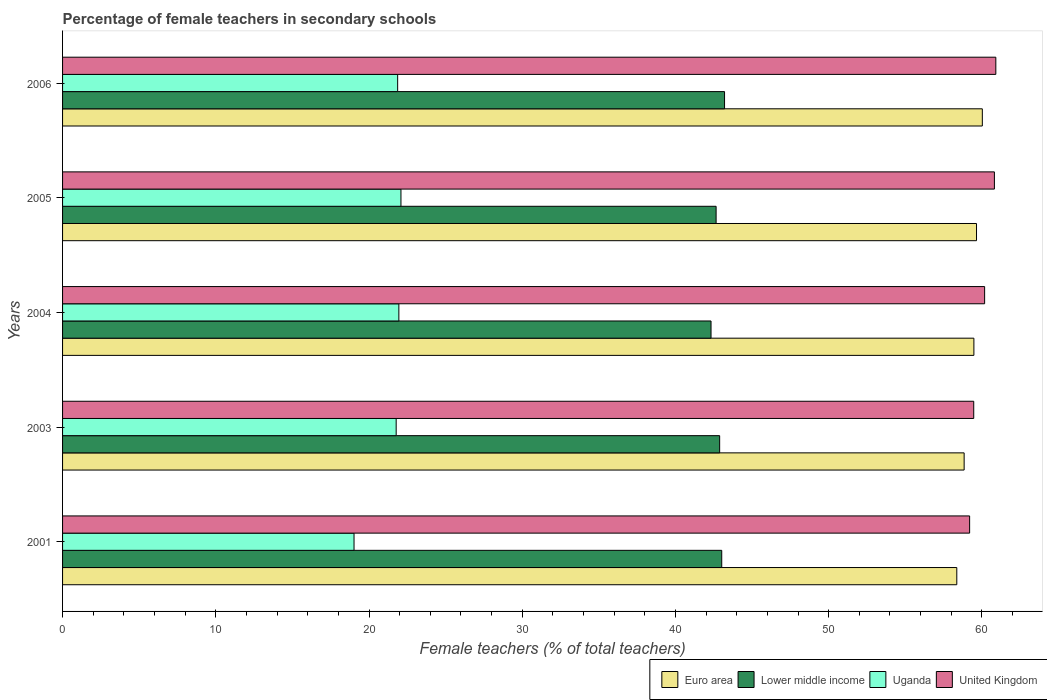How many different coloured bars are there?
Provide a succinct answer. 4. How many groups of bars are there?
Keep it short and to the point. 5. In how many cases, is the number of bars for a given year not equal to the number of legend labels?
Provide a succinct answer. 0. What is the percentage of female teachers in Lower middle income in 2004?
Your answer should be very brief. 42.32. Across all years, what is the maximum percentage of female teachers in Euro area?
Make the answer very short. 60.03. Across all years, what is the minimum percentage of female teachers in Uganda?
Your answer should be compact. 19.02. In which year was the percentage of female teachers in Euro area minimum?
Provide a short and direct response. 2001. What is the total percentage of female teachers in Uganda in the graph?
Give a very brief answer. 106.7. What is the difference between the percentage of female teachers in Lower middle income in 2001 and that in 2005?
Your response must be concise. 0.37. What is the difference between the percentage of female teachers in United Kingdom in 2006 and the percentage of female teachers in Lower middle income in 2001?
Your response must be concise. 17.89. What is the average percentage of female teachers in Lower middle income per year?
Your response must be concise. 42.82. In the year 2001, what is the difference between the percentage of female teachers in United Kingdom and percentage of female teachers in Uganda?
Give a very brief answer. 40.18. In how many years, is the percentage of female teachers in Lower middle income greater than 44 %?
Provide a short and direct response. 0. What is the ratio of the percentage of female teachers in United Kingdom in 2003 to that in 2006?
Offer a very short reply. 0.98. Is the percentage of female teachers in Lower middle income in 2003 less than that in 2004?
Offer a terse response. No. What is the difference between the highest and the second highest percentage of female teachers in United Kingdom?
Your answer should be very brief. 0.09. What is the difference between the highest and the lowest percentage of female teachers in Uganda?
Give a very brief answer. 3.06. What does the 3rd bar from the bottom in 2003 represents?
Provide a succinct answer. Uganda. How many bars are there?
Your answer should be very brief. 20. Are all the bars in the graph horizontal?
Keep it short and to the point. Yes. How many years are there in the graph?
Your response must be concise. 5. How are the legend labels stacked?
Provide a short and direct response. Horizontal. What is the title of the graph?
Your answer should be compact. Percentage of female teachers in secondary schools. Does "Morocco" appear as one of the legend labels in the graph?
Your response must be concise. No. What is the label or title of the X-axis?
Make the answer very short. Female teachers (% of total teachers). What is the Female teachers (% of total teachers) of Euro area in 2001?
Offer a terse response. 58.36. What is the Female teachers (% of total teachers) of Lower middle income in 2001?
Make the answer very short. 43.02. What is the Female teachers (% of total teachers) in Uganda in 2001?
Your response must be concise. 19.02. What is the Female teachers (% of total teachers) in United Kingdom in 2001?
Provide a succinct answer. 59.2. What is the Female teachers (% of total teachers) of Euro area in 2003?
Provide a succinct answer. 58.84. What is the Female teachers (% of total teachers) of Lower middle income in 2003?
Offer a terse response. 42.89. What is the Female teachers (% of total teachers) of Uganda in 2003?
Provide a succinct answer. 21.77. What is the Female teachers (% of total teachers) of United Kingdom in 2003?
Keep it short and to the point. 59.47. What is the Female teachers (% of total teachers) of Euro area in 2004?
Provide a short and direct response. 59.48. What is the Female teachers (% of total teachers) of Lower middle income in 2004?
Give a very brief answer. 42.32. What is the Female teachers (% of total teachers) in Uganda in 2004?
Give a very brief answer. 21.95. What is the Female teachers (% of total teachers) of United Kingdom in 2004?
Your answer should be compact. 60.18. What is the Female teachers (% of total teachers) of Euro area in 2005?
Give a very brief answer. 59.65. What is the Female teachers (% of total teachers) in Lower middle income in 2005?
Your answer should be very brief. 42.65. What is the Female teachers (% of total teachers) in Uganda in 2005?
Ensure brevity in your answer.  22.08. What is the Female teachers (% of total teachers) of United Kingdom in 2005?
Your answer should be compact. 60.82. What is the Female teachers (% of total teachers) of Euro area in 2006?
Offer a very short reply. 60.03. What is the Female teachers (% of total teachers) of Lower middle income in 2006?
Keep it short and to the point. 43.2. What is the Female teachers (% of total teachers) of Uganda in 2006?
Give a very brief answer. 21.87. What is the Female teachers (% of total teachers) of United Kingdom in 2006?
Make the answer very short. 60.91. Across all years, what is the maximum Female teachers (% of total teachers) in Euro area?
Your answer should be compact. 60.03. Across all years, what is the maximum Female teachers (% of total teachers) in Lower middle income?
Your answer should be compact. 43.2. Across all years, what is the maximum Female teachers (% of total teachers) of Uganda?
Give a very brief answer. 22.08. Across all years, what is the maximum Female teachers (% of total teachers) of United Kingdom?
Give a very brief answer. 60.91. Across all years, what is the minimum Female teachers (% of total teachers) in Euro area?
Make the answer very short. 58.36. Across all years, what is the minimum Female teachers (% of total teachers) of Lower middle income?
Make the answer very short. 42.32. Across all years, what is the minimum Female teachers (% of total teachers) of Uganda?
Offer a terse response. 19.02. Across all years, what is the minimum Female teachers (% of total teachers) of United Kingdom?
Your response must be concise. 59.2. What is the total Female teachers (% of total teachers) in Euro area in the graph?
Your answer should be very brief. 296.36. What is the total Female teachers (% of total teachers) in Lower middle income in the graph?
Ensure brevity in your answer.  214.09. What is the total Female teachers (% of total teachers) of Uganda in the graph?
Your response must be concise. 106.7. What is the total Female teachers (% of total teachers) of United Kingdom in the graph?
Make the answer very short. 300.57. What is the difference between the Female teachers (% of total teachers) of Euro area in 2001 and that in 2003?
Provide a short and direct response. -0.48. What is the difference between the Female teachers (% of total teachers) in Lower middle income in 2001 and that in 2003?
Your response must be concise. 0.14. What is the difference between the Female teachers (% of total teachers) in Uganda in 2001 and that in 2003?
Your answer should be very brief. -2.75. What is the difference between the Female teachers (% of total teachers) of United Kingdom in 2001 and that in 2003?
Offer a terse response. -0.27. What is the difference between the Female teachers (% of total teachers) in Euro area in 2001 and that in 2004?
Provide a short and direct response. -1.12. What is the difference between the Female teachers (% of total teachers) in Lower middle income in 2001 and that in 2004?
Ensure brevity in your answer.  0.7. What is the difference between the Female teachers (% of total teachers) in Uganda in 2001 and that in 2004?
Your answer should be compact. -2.93. What is the difference between the Female teachers (% of total teachers) of United Kingdom in 2001 and that in 2004?
Your answer should be very brief. -0.98. What is the difference between the Female teachers (% of total teachers) in Euro area in 2001 and that in 2005?
Give a very brief answer. -1.29. What is the difference between the Female teachers (% of total teachers) in Lower middle income in 2001 and that in 2005?
Your answer should be very brief. 0.37. What is the difference between the Female teachers (% of total teachers) of Uganda in 2001 and that in 2005?
Provide a succinct answer. -3.06. What is the difference between the Female teachers (% of total teachers) of United Kingdom in 2001 and that in 2005?
Keep it short and to the point. -1.62. What is the difference between the Female teachers (% of total teachers) of Euro area in 2001 and that in 2006?
Keep it short and to the point. -1.67. What is the difference between the Female teachers (% of total teachers) in Lower middle income in 2001 and that in 2006?
Your answer should be very brief. -0.18. What is the difference between the Female teachers (% of total teachers) of Uganda in 2001 and that in 2006?
Provide a succinct answer. -2.85. What is the difference between the Female teachers (% of total teachers) of United Kingdom in 2001 and that in 2006?
Your answer should be very brief. -1.71. What is the difference between the Female teachers (% of total teachers) of Euro area in 2003 and that in 2004?
Offer a very short reply. -0.64. What is the difference between the Female teachers (% of total teachers) in Lower middle income in 2003 and that in 2004?
Your answer should be very brief. 0.56. What is the difference between the Female teachers (% of total teachers) of Uganda in 2003 and that in 2004?
Keep it short and to the point. -0.18. What is the difference between the Female teachers (% of total teachers) of United Kingdom in 2003 and that in 2004?
Your response must be concise. -0.71. What is the difference between the Female teachers (% of total teachers) of Euro area in 2003 and that in 2005?
Offer a terse response. -0.81. What is the difference between the Female teachers (% of total teachers) of Lower middle income in 2003 and that in 2005?
Offer a terse response. 0.23. What is the difference between the Female teachers (% of total teachers) in Uganda in 2003 and that in 2005?
Give a very brief answer. -0.31. What is the difference between the Female teachers (% of total teachers) of United Kingdom in 2003 and that in 2005?
Your answer should be compact. -1.35. What is the difference between the Female teachers (% of total teachers) in Euro area in 2003 and that in 2006?
Give a very brief answer. -1.19. What is the difference between the Female teachers (% of total teachers) of Lower middle income in 2003 and that in 2006?
Give a very brief answer. -0.32. What is the difference between the Female teachers (% of total teachers) in Uganda in 2003 and that in 2006?
Make the answer very short. -0.1. What is the difference between the Female teachers (% of total teachers) of United Kingdom in 2003 and that in 2006?
Your answer should be compact. -1.44. What is the difference between the Female teachers (% of total teachers) of Euro area in 2004 and that in 2005?
Give a very brief answer. -0.17. What is the difference between the Female teachers (% of total teachers) in Lower middle income in 2004 and that in 2005?
Your response must be concise. -0.33. What is the difference between the Female teachers (% of total teachers) in Uganda in 2004 and that in 2005?
Your response must be concise. -0.14. What is the difference between the Female teachers (% of total teachers) in United Kingdom in 2004 and that in 2005?
Ensure brevity in your answer.  -0.64. What is the difference between the Female teachers (% of total teachers) of Euro area in 2004 and that in 2006?
Keep it short and to the point. -0.55. What is the difference between the Female teachers (% of total teachers) of Lower middle income in 2004 and that in 2006?
Make the answer very short. -0.88. What is the difference between the Female teachers (% of total teachers) of Uganda in 2004 and that in 2006?
Provide a short and direct response. 0.08. What is the difference between the Female teachers (% of total teachers) in United Kingdom in 2004 and that in 2006?
Provide a short and direct response. -0.73. What is the difference between the Female teachers (% of total teachers) in Euro area in 2005 and that in 2006?
Keep it short and to the point. -0.38. What is the difference between the Female teachers (% of total teachers) in Lower middle income in 2005 and that in 2006?
Make the answer very short. -0.55. What is the difference between the Female teachers (% of total teachers) of Uganda in 2005 and that in 2006?
Your answer should be very brief. 0.21. What is the difference between the Female teachers (% of total teachers) in United Kingdom in 2005 and that in 2006?
Provide a succinct answer. -0.09. What is the difference between the Female teachers (% of total teachers) of Euro area in 2001 and the Female teachers (% of total teachers) of Lower middle income in 2003?
Provide a short and direct response. 15.48. What is the difference between the Female teachers (% of total teachers) in Euro area in 2001 and the Female teachers (% of total teachers) in Uganda in 2003?
Your answer should be very brief. 36.59. What is the difference between the Female teachers (% of total teachers) in Euro area in 2001 and the Female teachers (% of total teachers) in United Kingdom in 2003?
Provide a succinct answer. -1.11. What is the difference between the Female teachers (% of total teachers) of Lower middle income in 2001 and the Female teachers (% of total teachers) of Uganda in 2003?
Provide a short and direct response. 21.25. What is the difference between the Female teachers (% of total teachers) in Lower middle income in 2001 and the Female teachers (% of total teachers) in United Kingdom in 2003?
Your answer should be very brief. -16.45. What is the difference between the Female teachers (% of total teachers) in Uganda in 2001 and the Female teachers (% of total teachers) in United Kingdom in 2003?
Give a very brief answer. -40.45. What is the difference between the Female teachers (% of total teachers) of Euro area in 2001 and the Female teachers (% of total teachers) of Lower middle income in 2004?
Your answer should be compact. 16.04. What is the difference between the Female teachers (% of total teachers) in Euro area in 2001 and the Female teachers (% of total teachers) in Uganda in 2004?
Offer a very short reply. 36.41. What is the difference between the Female teachers (% of total teachers) of Euro area in 2001 and the Female teachers (% of total teachers) of United Kingdom in 2004?
Give a very brief answer. -1.82. What is the difference between the Female teachers (% of total teachers) in Lower middle income in 2001 and the Female teachers (% of total teachers) in Uganda in 2004?
Keep it short and to the point. 21.07. What is the difference between the Female teachers (% of total teachers) of Lower middle income in 2001 and the Female teachers (% of total teachers) of United Kingdom in 2004?
Offer a very short reply. -17.16. What is the difference between the Female teachers (% of total teachers) of Uganda in 2001 and the Female teachers (% of total teachers) of United Kingdom in 2004?
Give a very brief answer. -41.16. What is the difference between the Female teachers (% of total teachers) of Euro area in 2001 and the Female teachers (% of total teachers) of Lower middle income in 2005?
Give a very brief answer. 15.71. What is the difference between the Female teachers (% of total teachers) in Euro area in 2001 and the Female teachers (% of total teachers) in Uganda in 2005?
Offer a very short reply. 36.28. What is the difference between the Female teachers (% of total teachers) in Euro area in 2001 and the Female teachers (% of total teachers) in United Kingdom in 2005?
Offer a terse response. -2.45. What is the difference between the Female teachers (% of total teachers) of Lower middle income in 2001 and the Female teachers (% of total teachers) of Uganda in 2005?
Make the answer very short. 20.94. What is the difference between the Female teachers (% of total teachers) of Lower middle income in 2001 and the Female teachers (% of total teachers) of United Kingdom in 2005?
Provide a short and direct response. -17.8. What is the difference between the Female teachers (% of total teachers) of Uganda in 2001 and the Female teachers (% of total teachers) of United Kingdom in 2005?
Ensure brevity in your answer.  -41.79. What is the difference between the Female teachers (% of total teachers) of Euro area in 2001 and the Female teachers (% of total teachers) of Lower middle income in 2006?
Offer a very short reply. 15.16. What is the difference between the Female teachers (% of total teachers) of Euro area in 2001 and the Female teachers (% of total teachers) of Uganda in 2006?
Provide a short and direct response. 36.49. What is the difference between the Female teachers (% of total teachers) in Euro area in 2001 and the Female teachers (% of total teachers) in United Kingdom in 2006?
Provide a succinct answer. -2.55. What is the difference between the Female teachers (% of total teachers) in Lower middle income in 2001 and the Female teachers (% of total teachers) in Uganda in 2006?
Keep it short and to the point. 21.15. What is the difference between the Female teachers (% of total teachers) in Lower middle income in 2001 and the Female teachers (% of total teachers) in United Kingdom in 2006?
Ensure brevity in your answer.  -17.89. What is the difference between the Female teachers (% of total teachers) of Uganda in 2001 and the Female teachers (% of total teachers) of United Kingdom in 2006?
Make the answer very short. -41.89. What is the difference between the Female teachers (% of total teachers) of Euro area in 2003 and the Female teachers (% of total teachers) of Lower middle income in 2004?
Ensure brevity in your answer.  16.52. What is the difference between the Female teachers (% of total teachers) in Euro area in 2003 and the Female teachers (% of total teachers) in Uganda in 2004?
Provide a succinct answer. 36.89. What is the difference between the Female teachers (% of total teachers) in Euro area in 2003 and the Female teachers (% of total teachers) in United Kingdom in 2004?
Your response must be concise. -1.34. What is the difference between the Female teachers (% of total teachers) of Lower middle income in 2003 and the Female teachers (% of total teachers) of Uganda in 2004?
Give a very brief answer. 20.94. What is the difference between the Female teachers (% of total teachers) in Lower middle income in 2003 and the Female teachers (% of total teachers) in United Kingdom in 2004?
Your answer should be very brief. -17.29. What is the difference between the Female teachers (% of total teachers) in Uganda in 2003 and the Female teachers (% of total teachers) in United Kingdom in 2004?
Provide a succinct answer. -38.41. What is the difference between the Female teachers (% of total teachers) of Euro area in 2003 and the Female teachers (% of total teachers) of Lower middle income in 2005?
Provide a succinct answer. 16.19. What is the difference between the Female teachers (% of total teachers) of Euro area in 2003 and the Female teachers (% of total teachers) of Uganda in 2005?
Your answer should be compact. 36.76. What is the difference between the Female teachers (% of total teachers) of Euro area in 2003 and the Female teachers (% of total teachers) of United Kingdom in 2005?
Provide a short and direct response. -1.98. What is the difference between the Female teachers (% of total teachers) in Lower middle income in 2003 and the Female teachers (% of total teachers) in Uganda in 2005?
Your response must be concise. 20.8. What is the difference between the Female teachers (% of total teachers) in Lower middle income in 2003 and the Female teachers (% of total teachers) in United Kingdom in 2005?
Provide a succinct answer. -17.93. What is the difference between the Female teachers (% of total teachers) of Uganda in 2003 and the Female teachers (% of total teachers) of United Kingdom in 2005?
Provide a short and direct response. -39.04. What is the difference between the Female teachers (% of total teachers) of Euro area in 2003 and the Female teachers (% of total teachers) of Lower middle income in 2006?
Your answer should be compact. 15.64. What is the difference between the Female teachers (% of total teachers) of Euro area in 2003 and the Female teachers (% of total teachers) of Uganda in 2006?
Ensure brevity in your answer.  36.97. What is the difference between the Female teachers (% of total teachers) in Euro area in 2003 and the Female teachers (% of total teachers) in United Kingdom in 2006?
Your response must be concise. -2.07. What is the difference between the Female teachers (% of total teachers) in Lower middle income in 2003 and the Female teachers (% of total teachers) in Uganda in 2006?
Make the answer very short. 21.02. What is the difference between the Female teachers (% of total teachers) in Lower middle income in 2003 and the Female teachers (% of total teachers) in United Kingdom in 2006?
Your answer should be compact. -18.02. What is the difference between the Female teachers (% of total teachers) of Uganda in 2003 and the Female teachers (% of total teachers) of United Kingdom in 2006?
Offer a very short reply. -39.14. What is the difference between the Female teachers (% of total teachers) in Euro area in 2004 and the Female teachers (% of total teachers) in Lower middle income in 2005?
Your response must be concise. 16.82. What is the difference between the Female teachers (% of total teachers) in Euro area in 2004 and the Female teachers (% of total teachers) in Uganda in 2005?
Provide a succinct answer. 37.39. What is the difference between the Female teachers (% of total teachers) in Euro area in 2004 and the Female teachers (% of total teachers) in United Kingdom in 2005?
Make the answer very short. -1.34. What is the difference between the Female teachers (% of total teachers) of Lower middle income in 2004 and the Female teachers (% of total teachers) of Uganda in 2005?
Provide a short and direct response. 20.24. What is the difference between the Female teachers (% of total teachers) of Lower middle income in 2004 and the Female teachers (% of total teachers) of United Kingdom in 2005?
Ensure brevity in your answer.  -18.49. What is the difference between the Female teachers (% of total teachers) in Uganda in 2004 and the Female teachers (% of total teachers) in United Kingdom in 2005?
Your response must be concise. -38.87. What is the difference between the Female teachers (% of total teachers) of Euro area in 2004 and the Female teachers (% of total teachers) of Lower middle income in 2006?
Provide a short and direct response. 16.27. What is the difference between the Female teachers (% of total teachers) in Euro area in 2004 and the Female teachers (% of total teachers) in Uganda in 2006?
Keep it short and to the point. 37.61. What is the difference between the Female teachers (% of total teachers) of Euro area in 2004 and the Female teachers (% of total teachers) of United Kingdom in 2006?
Ensure brevity in your answer.  -1.43. What is the difference between the Female teachers (% of total teachers) of Lower middle income in 2004 and the Female teachers (% of total teachers) of Uganda in 2006?
Your answer should be compact. 20.45. What is the difference between the Female teachers (% of total teachers) of Lower middle income in 2004 and the Female teachers (% of total teachers) of United Kingdom in 2006?
Offer a terse response. -18.59. What is the difference between the Female teachers (% of total teachers) in Uganda in 2004 and the Female teachers (% of total teachers) in United Kingdom in 2006?
Provide a short and direct response. -38.96. What is the difference between the Female teachers (% of total teachers) in Euro area in 2005 and the Female teachers (% of total teachers) in Lower middle income in 2006?
Your answer should be very brief. 16.44. What is the difference between the Female teachers (% of total teachers) in Euro area in 2005 and the Female teachers (% of total teachers) in Uganda in 2006?
Your answer should be compact. 37.78. What is the difference between the Female teachers (% of total teachers) of Euro area in 2005 and the Female teachers (% of total teachers) of United Kingdom in 2006?
Offer a terse response. -1.26. What is the difference between the Female teachers (% of total teachers) in Lower middle income in 2005 and the Female teachers (% of total teachers) in Uganda in 2006?
Offer a very short reply. 20.78. What is the difference between the Female teachers (% of total teachers) of Lower middle income in 2005 and the Female teachers (% of total teachers) of United Kingdom in 2006?
Make the answer very short. -18.26. What is the difference between the Female teachers (% of total teachers) of Uganda in 2005 and the Female teachers (% of total teachers) of United Kingdom in 2006?
Your answer should be compact. -38.83. What is the average Female teachers (% of total teachers) in Euro area per year?
Offer a terse response. 59.27. What is the average Female teachers (% of total teachers) of Lower middle income per year?
Offer a terse response. 42.82. What is the average Female teachers (% of total teachers) of Uganda per year?
Give a very brief answer. 21.34. What is the average Female teachers (% of total teachers) in United Kingdom per year?
Your answer should be very brief. 60.12. In the year 2001, what is the difference between the Female teachers (% of total teachers) of Euro area and Female teachers (% of total teachers) of Lower middle income?
Your response must be concise. 15.34. In the year 2001, what is the difference between the Female teachers (% of total teachers) in Euro area and Female teachers (% of total teachers) in Uganda?
Give a very brief answer. 39.34. In the year 2001, what is the difference between the Female teachers (% of total teachers) of Euro area and Female teachers (% of total teachers) of United Kingdom?
Give a very brief answer. -0.84. In the year 2001, what is the difference between the Female teachers (% of total teachers) of Lower middle income and Female teachers (% of total teachers) of Uganda?
Provide a short and direct response. 24. In the year 2001, what is the difference between the Female teachers (% of total teachers) in Lower middle income and Female teachers (% of total teachers) in United Kingdom?
Keep it short and to the point. -16.18. In the year 2001, what is the difference between the Female teachers (% of total teachers) in Uganda and Female teachers (% of total teachers) in United Kingdom?
Give a very brief answer. -40.18. In the year 2003, what is the difference between the Female teachers (% of total teachers) in Euro area and Female teachers (% of total teachers) in Lower middle income?
Provide a short and direct response. 15.96. In the year 2003, what is the difference between the Female teachers (% of total teachers) of Euro area and Female teachers (% of total teachers) of Uganda?
Make the answer very short. 37.07. In the year 2003, what is the difference between the Female teachers (% of total teachers) in Euro area and Female teachers (% of total teachers) in United Kingdom?
Your answer should be compact. -0.63. In the year 2003, what is the difference between the Female teachers (% of total teachers) in Lower middle income and Female teachers (% of total teachers) in Uganda?
Your answer should be compact. 21.11. In the year 2003, what is the difference between the Female teachers (% of total teachers) of Lower middle income and Female teachers (% of total teachers) of United Kingdom?
Offer a very short reply. -16.58. In the year 2003, what is the difference between the Female teachers (% of total teachers) in Uganda and Female teachers (% of total teachers) in United Kingdom?
Your response must be concise. -37.7. In the year 2004, what is the difference between the Female teachers (% of total teachers) in Euro area and Female teachers (% of total teachers) in Lower middle income?
Offer a terse response. 17.16. In the year 2004, what is the difference between the Female teachers (% of total teachers) in Euro area and Female teachers (% of total teachers) in Uganda?
Ensure brevity in your answer.  37.53. In the year 2004, what is the difference between the Female teachers (% of total teachers) of Euro area and Female teachers (% of total teachers) of United Kingdom?
Offer a terse response. -0.7. In the year 2004, what is the difference between the Female teachers (% of total teachers) in Lower middle income and Female teachers (% of total teachers) in Uganda?
Make the answer very short. 20.37. In the year 2004, what is the difference between the Female teachers (% of total teachers) in Lower middle income and Female teachers (% of total teachers) in United Kingdom?
Make the answer very short. -17.86. In the year 2004, what is the difference between the Female teachers (% of total teachers) in Uganda and Female teachers (% of total teachers) in United Kingdom?
Offer a terse response. -38.23. In the year 2005, what is the difference between the Female teachers (% of total teachers) of Euro area and Female teachers (% of total teachers) of Lower middle income?
Ensure brevity in your answer.  17. In the year 2005, what is the difference between the Female teachers (% of total teachers) in Euro area and Female teachers (% of total teachers) in Uganda?
Give a very brief answer. 37.56. In the year 2005, what is the difference between the Female teachers (% of total teachers) in Euro area and Female teachers (% of total teachers) in United Kingdom?
Your answer should be compact. -1.17. In the year 2005, what is the difference between the Female teachers (% of total teachers) in Lower middle income and Female teachers (% of total teachers) in Uganda?
Keep it short and to the point. 20.57. In the year 2005, what is the difference between the Female teachers (% of total teachers) of Lower middle income and Female teachers (% of total teachers) of United Kingdom?
Your answer should be very brief. -18.16. In the year 2005, what is the difference between the Female teachers (% of total teachers) in Uganda and Female teachers (% of total teachers) in United Kingdom?
Your answer should be compact. -38.73. In the year 2006, what is the difference between the Female teachers (% of total teachers) of Euro area and Female teachers (% of total teachers) of Lower middle income?
Provide a short and direct response. 16.82. In the year 2006, what is the difference between the Female teachers (% of total teachers) in Euro area and Female teachers (% of total teachers) in Uganda?
Provide a short and direct response. 38.16. In the year 2006, what is the difference between the Female teachers (% of total teachers) of Euro area and Female teachers (% of total teachers) of United Kingdom?
Make the answer very short. -0.88. In the year 2006, what is the difference between the Female teachers (% of total teachers) in Lower middle income and Female teachers (% of total teachers) in Uganda?
Your answer should be very brief. 21.33. In the year 2006, what is the difference between the Female teachers (% of total teachers) of Lower middle income and Female teachers (% of total teachers) of United Kingdom?
Provide a succinct answer. -17.71. In the year 2006, what is the difference between the Female teachers (% of total teachers) in Uganda and Female teachers (% of total teachers) in United Kingdom?
Make the answer very short. -39.04. What is the ratio of the Female teachers (% of total teachers) of Euro area in 2001 to that in 2003?
Provide a succinct answer. 0.99. What is the ratio of the Female teachers (% of total teachers) in Lower middle income in 2001 to that in 2003?
Ensure brevity in your answer.  1. What is the ratio of the Female teachers (% of total teachers) in Uganda in 2001 to that in 2003?
Give a very brief answer. 0.87. What is the ratio of the Female teachers (% of total teachers) in United Kingdom in 2001 to that in 2003?
Keep it short and to the point. 1. What is the ratio of the Female teachers (% of total teachers) in Euro area in 2001 to that in 2004?
Ensure brevity in your answer.  0.98. What is the ratio of the Female teachers (% of total teachers) of Lower middle income in 2001 to that in 2004?
Your response must be concise. 1.02. What is the ratio of the Female teachers (% of total teachers) of Uganda in 2001 to that in 2004?
Provide a succinct answer. 0.87. What is the ratio of the Female teachers (% of total teachers) in United Kingdom in 2001 to that in 2004?
Your answer should be very brief. 0.98. What is the ratio of the Female teachers (% of total teachers) in Euro area in 2001 to that in 2005?
Give a very brief answer. 0.98. What is the ratio of the Female teachers (% of total teachers) of Lower middle income in 2001 to that in 2005?
Offer a very short reply. 1.01. What is the ratio of the Female teachers (% of total teachers) of Uganda in 2001 to that in 2005?
Make the answer very short. 0.86. What is the ratio of the Female teachers (% of total teachers) in United Kingdom in 2001 to that in 2005?
Your response must be concise. 0.97. What is the ratio of the Female teachers (% of total teachers) of Euro area in 2001 to that in 2006?
Your answer should be very brief. 0.97. What is the ratio of the Female teachers (% of total teachers) of Uganda in 2001 to that in 2006?
Provide a succinct answer. 0.87. What is the ratio of the Female teachers (% of total teachers) in United Kingdom in 2001 to that in 2006?
Your answer should be compact. 0.97. What is the ratio of the Female teachers (% of total teachers) of Euro area in 2003 to that in 2004?
Your answer should be compact. 0.99. What is the ratio of the Female teachers (% of total teachers) of Lower middle income in 2003 to that in 2004?
Keep it short and to the point. 1.01. What is the ratio of the Female teachers (% of total teachers) of Euro area in 2003 to that in 2005?
Provide a short and direct response. 0.99. What is the ratio of the Female teachers (% of total teachers) of Lower middle income in 2003 to that in 2005?
Your response must be concise. 1.01. What is the ratio of the Female teachers (% of total teachers) of Uganda in 2003 to that in 2005?
Provide a short and direct response. 0.99. What is the ratio of the Female teachers (% of total teachers) of United Kingdom in 2003 to that in 2005?
Provide a short and direct response. 0.98. What is the ratio of the Female teachers (% of total teachers) in Euro area in 2003 to that in 2006?
Provide a succinct answer. 0.98. What is the ratio of the Female teachers (% of total teachers) of Uganda in 2003 to that in 2006?
Offer a very short reply. 1. What is the ratio of the Female teachers (% of total teachers) in United Kingdom in 2003 to that in 2006?
Give a very brief answer. 0.98. What is the ratio of the Female teachers (% of total teachers) in Euro area in 2004 to that in 2005?
Give a very brief answer. 1. What is the ratio of the Female teachers (% of total teachers) in Lower middle income in 2004 to that in 2005?
Give a very brief answer. 0.99. What is the ratio of the Female teachers (% of total teachers) of Uganda in 2004 to that in 2005?
Your answer should be compact. 0.99. What is the ratio of the Female teachers (% of total teachers) of United Kingdom in 2004 to that in 2005?
Offer a very short reply. 0.99. What is the ratio of the Female teachers (% of total teachers) of Euro area in 2004 to that in 2006?
Make the answer very short. 0.99. What is the ratio of the Female teachers (% of total teachers) of Lower middle income in 2004 to that in 2006?
Keep it short and to the point. 0.98. What is the ratio of the Female teachers (% of total teachers) in Uganda in 2004 to that in 2006?
Your answer should be compact. 1. What is the ratio of the Female teachers (% of total teachers) of Euro area in 2005 to that in 2006?
Keep it short and to the point. 0.99. What is the ratio of the Female teachers (% of total teachers) of Lower middle income in 2005 to that in 2006?
Your answer should be compact. 0.99. What is the ratio of the Female teachers (% of total teachers) of Uganda in 2005 to that in 2006?
Your answer should be very brief. 1.01. What is the ratio of the Female teachers (% of total teachers) in United Kingdom in 2005 to that in 2006?
Provide a succinct answer. 1. What is the difference between the highest and the second highest Female teachers (% of total teachers) of Euro area?
Offer a very short reply. 0.38. What is the difference between the highest and the second highest Female teachers (% of total teachers) of Lower middle income?
Your response must be concise. 0.18. What is the difference between the highest and the second highest Female teachers (% of total teachers) in Uganda?
Give a very brief answer. 0.14. What is the difference between the highest and the second highest Female teachers (% of total teachers) in United Kingdom?
Your answer should be compact. 0.09. What is the difference between the highest and the lowest Female teachers (% of total teachers) of Euro area?
Make the answer very short. 1.67. What is the difference between the highest and the lowest Female teachers (% of total teachers) of Lower middle income?
Make the answer very short. 0.88. What is the difference between the highest and the lowest Female teachers (% of total teachers) in Uganda?
Provide a succinct answer. 3.06. What is the difference between the highest and the lowest Female teachers (% of total teachers) of United Kingdom?
Your answer should be compact. 1.71. 